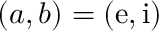<formula> <loc_0><loc_0><loc_500><loc_500>( a , b ) = ( e , i )</formula> 